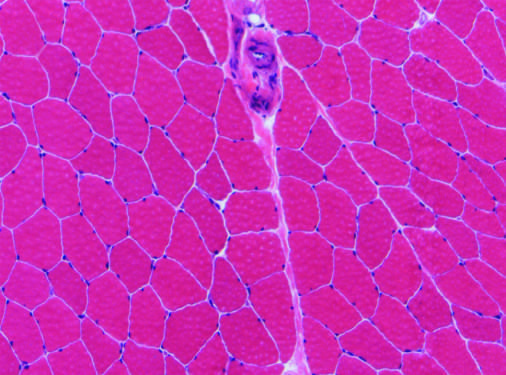what has relatively uniform polygonal myofibers with peripherally placed nuclei that are tightly packed together into fascicles separated by scant connective tissue?
Answer the question using a single word or phrase. Normal skeletal muscle tissue 